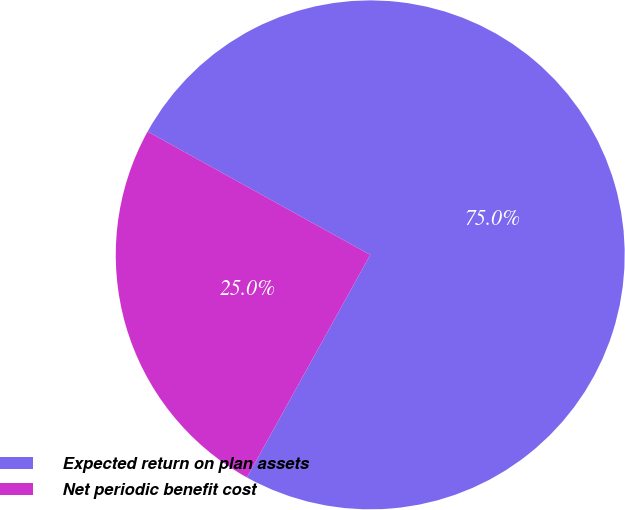<chart> <loc_0><loc_0><loc_500><loc_500><pie_chart><fcel>Expected return on plan assets<fcel>Net periodic benefit cost<nl><fcel>75.0%<fcel>25.0%<nl></chart> 